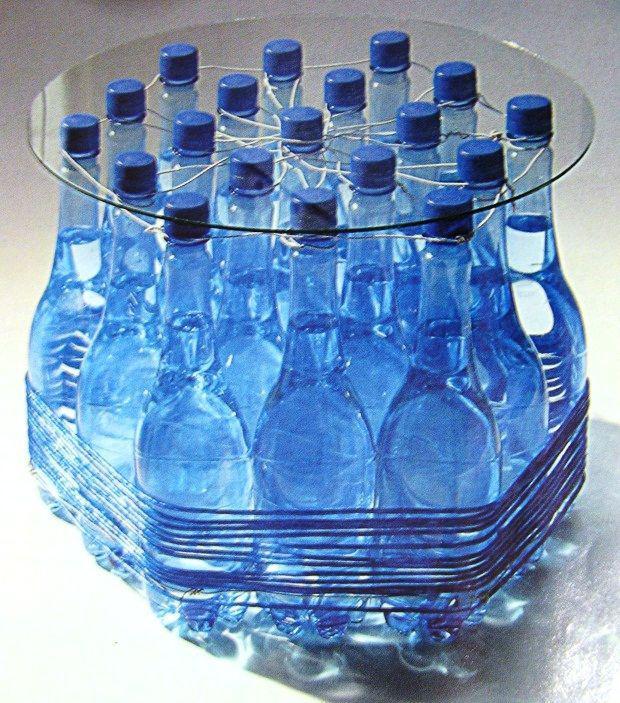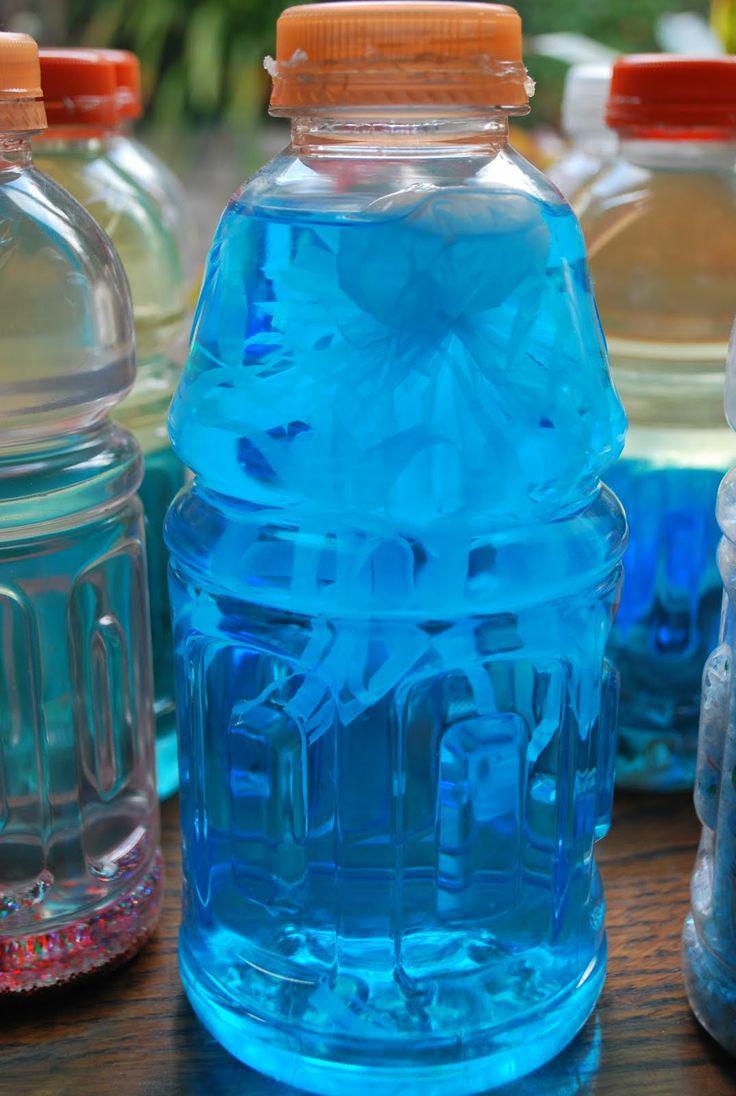The first image is the image on the left, the second image is the image on the right. Examine the images to the left and right. Is the description "An image shows bottles with orange lids." accurate? Answer yes or no. Yes. 